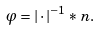<formula> <loc_0><loc_0><loc_500><loc_500>\varphi = | \cdot | ^ { - 1 } * n .</formula> 